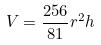Convert formula to latex. <formula><loc_0><loc_0><loc_500><loc_500>V = \frac { 2 5 6 } { 8 1 } r ^ { 2 } h</formula> 